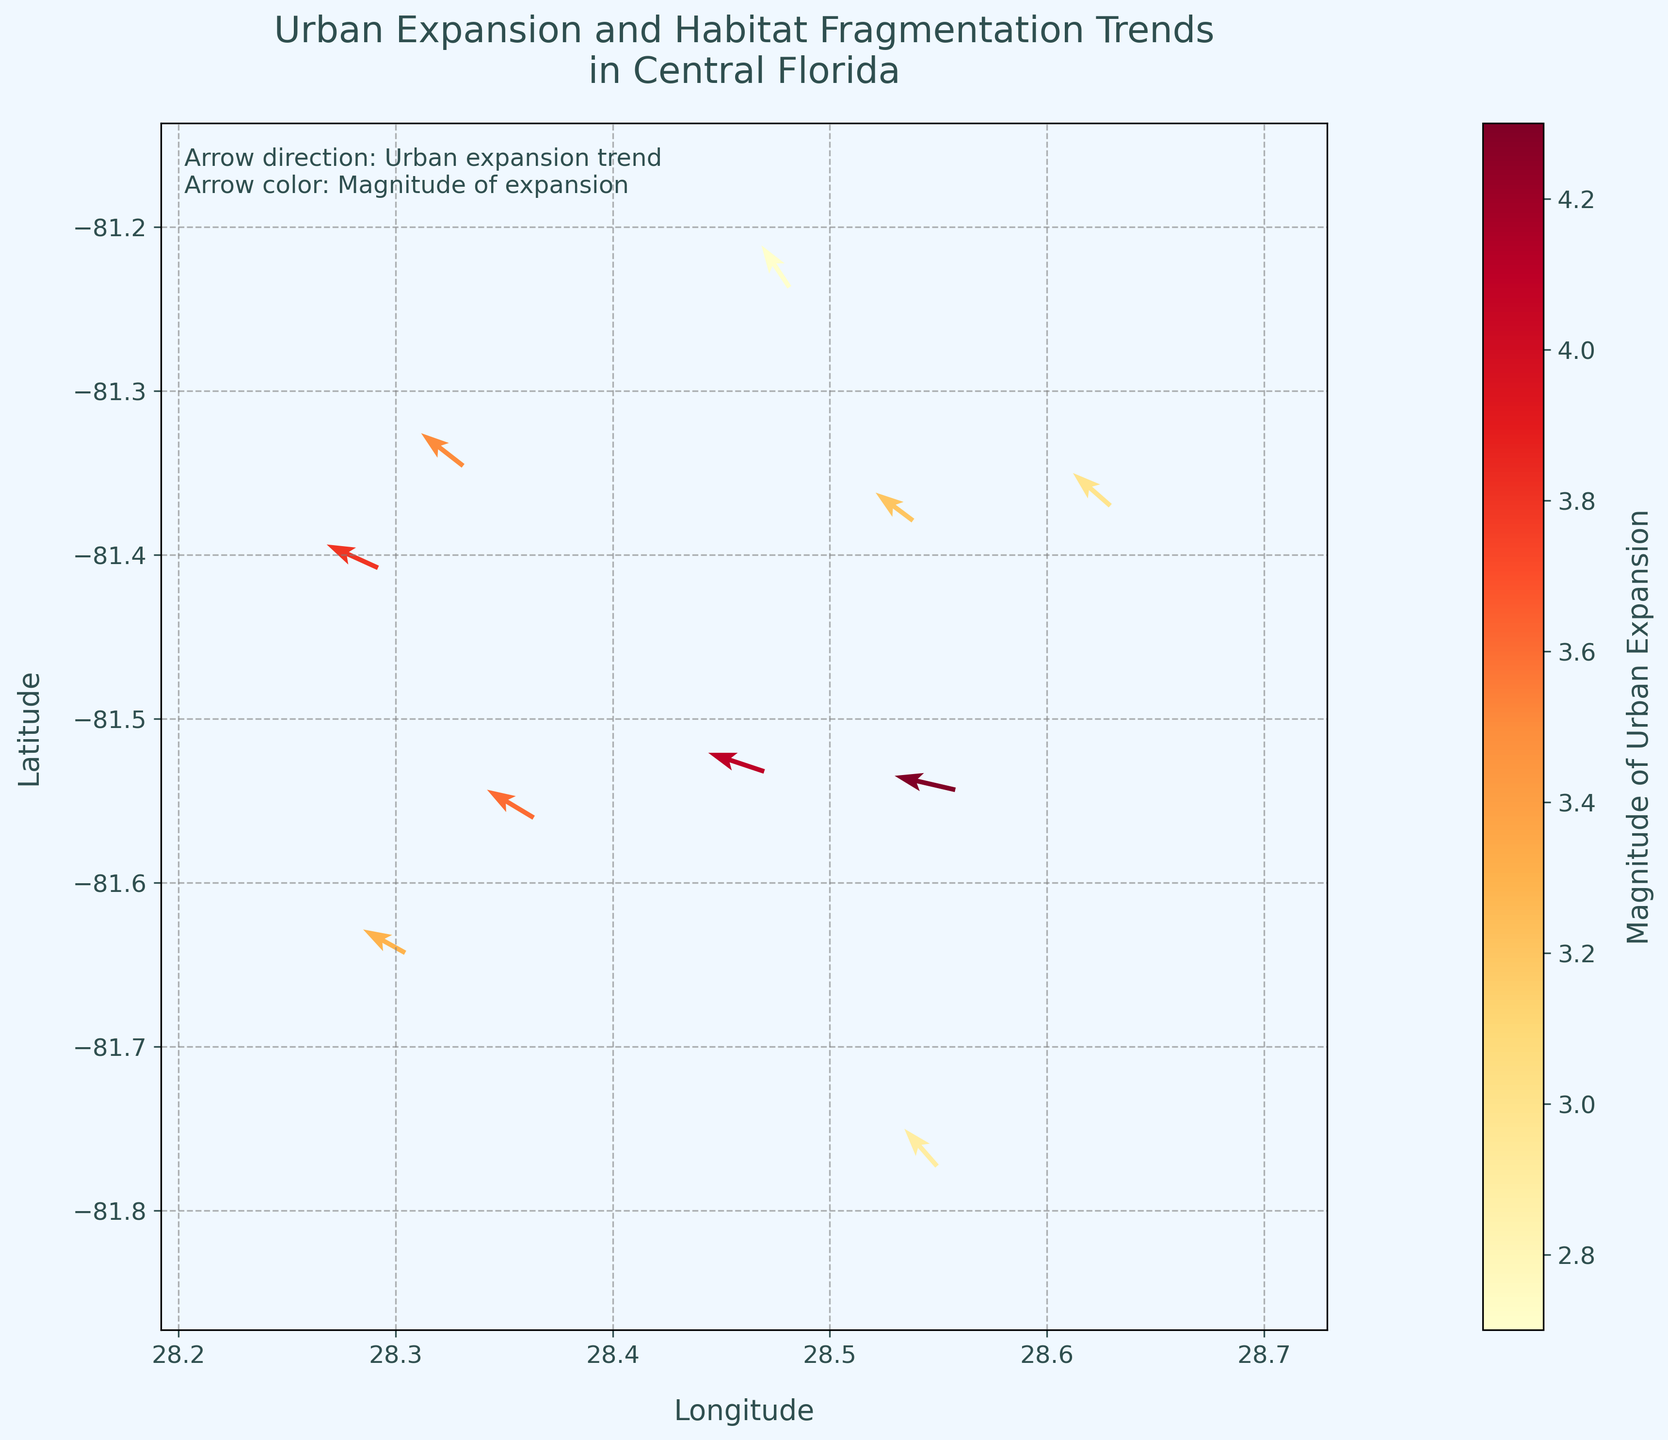What is the title of the plot? The title of the plot is displayed at the top of the figure. It reads 'Urban Expansion and Habitat Fragmentation Trends in Central Florida'.
Answer: Urban Expansion and Habitat Fragmentation Trends in Central Florida How many data points are shown in the plot? Count the number of arrows representing the data points on the plot. Each arrow represents one data point. There are 10 arrows in total.
Answer: 10 What is the range of latitude values shown in the plot? Check the y-axis limits of the plot to determine the range of latitude values. The y-axis limits are slightly below and above the data points' minimum and maximum y-values.
Answer: Approximately 28.2 to 28.7 degrees What does the color of the arrows represent? There is a text annotation on the plot that explains the meaning of the arrow color. It states that the arrow color represents the 'Magnitude of Urban Expansion’.
Answer: Magnitude of Urban Expansion Which location among the data points has the highest magnitude of urban expansion? Look at the color intensity of the arrows or the color bar scale and identify the arrow with the highest magnitude value. The data point for 28.5578,-81.5434 has the highest magnitude value of 4.3.
Answer: 28.5578,-81.5434 What is the general direction of urban expansion trends in Central Florida based on the arrows' directions? Observing the direction of the arrows, most of them point in the general southwest direction. This indicates a trend of urban expansion towards the southwest in Central Florida.
Answer: Southwest Which data point shows the highest magnitude but least directional inclination? The data point at 28.5578,-81.5434 has the highest magnitude, indicated by the deepest color hue, with an arrow direction close to horizontal (least directional inclination, u=-1.3, v=0.3).
Answer: 28.5578,-81.5434 Comparing the magnitude of urban expansion at 28.5383,-81.3792 and 28.5494,-81.7729, which is higher? Refer to the magnitude values provided for each data point. The magnitude for 28.5383,-81.3792 is 3.2, while the magnitude for 28.5494,-81.7729 is 2.9. Hence, 28.5383,-81.3792 is higher.
Answer: 28.5383,-81.3792 What is the average magnitude of urban expansion for all the data points shown? Sum the magnitude values provided for each data point and divide by the number of data points. (3.2 + 4.1 + 3.5 + 3.8 + 2.9 + 3.6 + 2.7 + 3.0 + 4.3 + 3.3) / 10 = 3.44
Answer: 3.44 